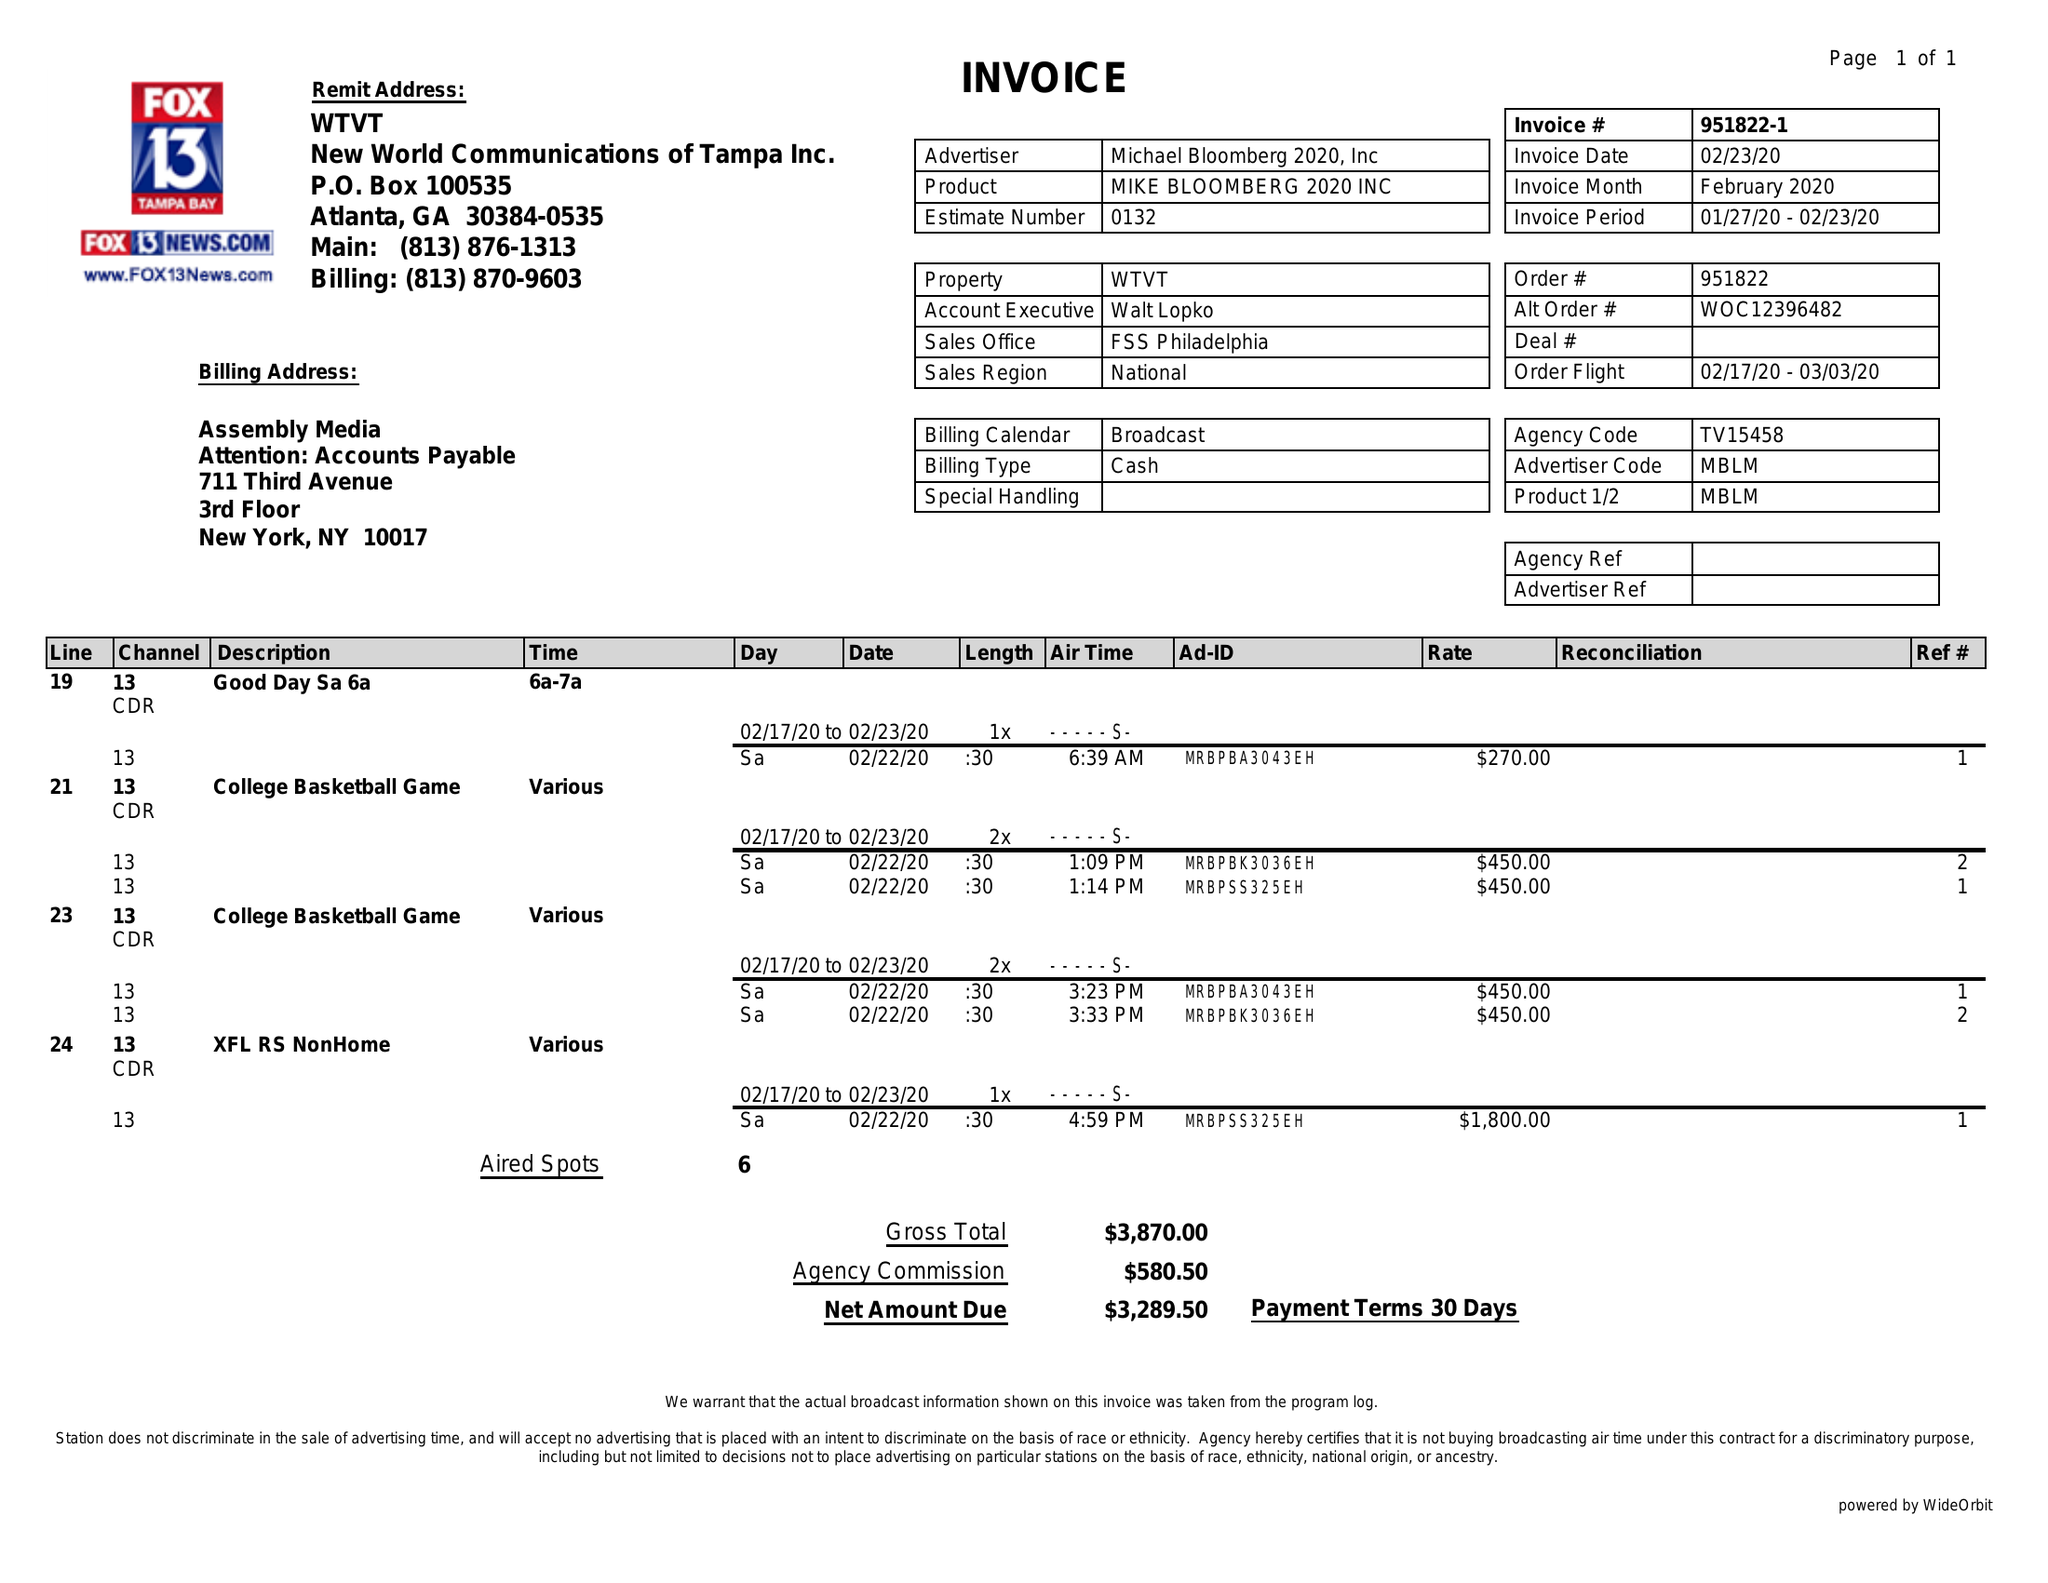What is the value for the flight_from?
Answer the question using a single word or phrase. 02/17/20 